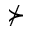Convert formula to latex. <formula><loc_0><loc_0><loc_500><loc_500>\nsucc</formula> 